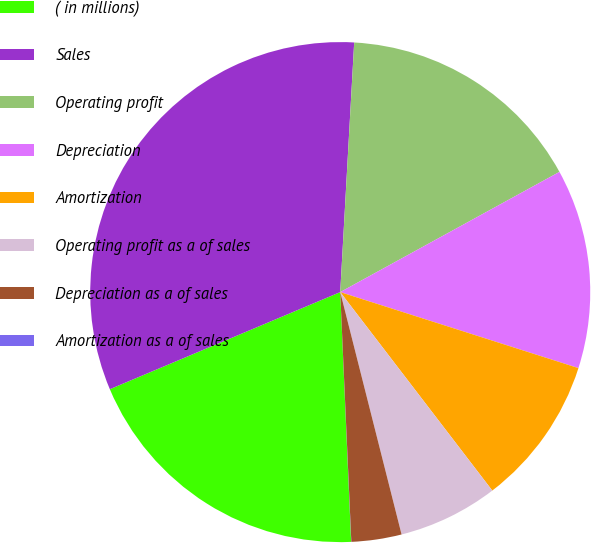<chart> <loc_0><loc_0><loc_500><loc_500><pie_chart><fcel>( in millions)<fcel>Sales<fcel>Operating profit<fcel>Depreciation<fcel>Amortization<fcel>Operating profit as a of sales<fcel>Depreciation as a of sales<fcel>Amortization as a of sales<nl><fcel>19.35%<fcel>32.24%<fcel>16.13%<fcel>12.9%<fcel>9.68%<fcel>6.46%<fcel>3.24%<fcel>0.01%<nl></chart> 